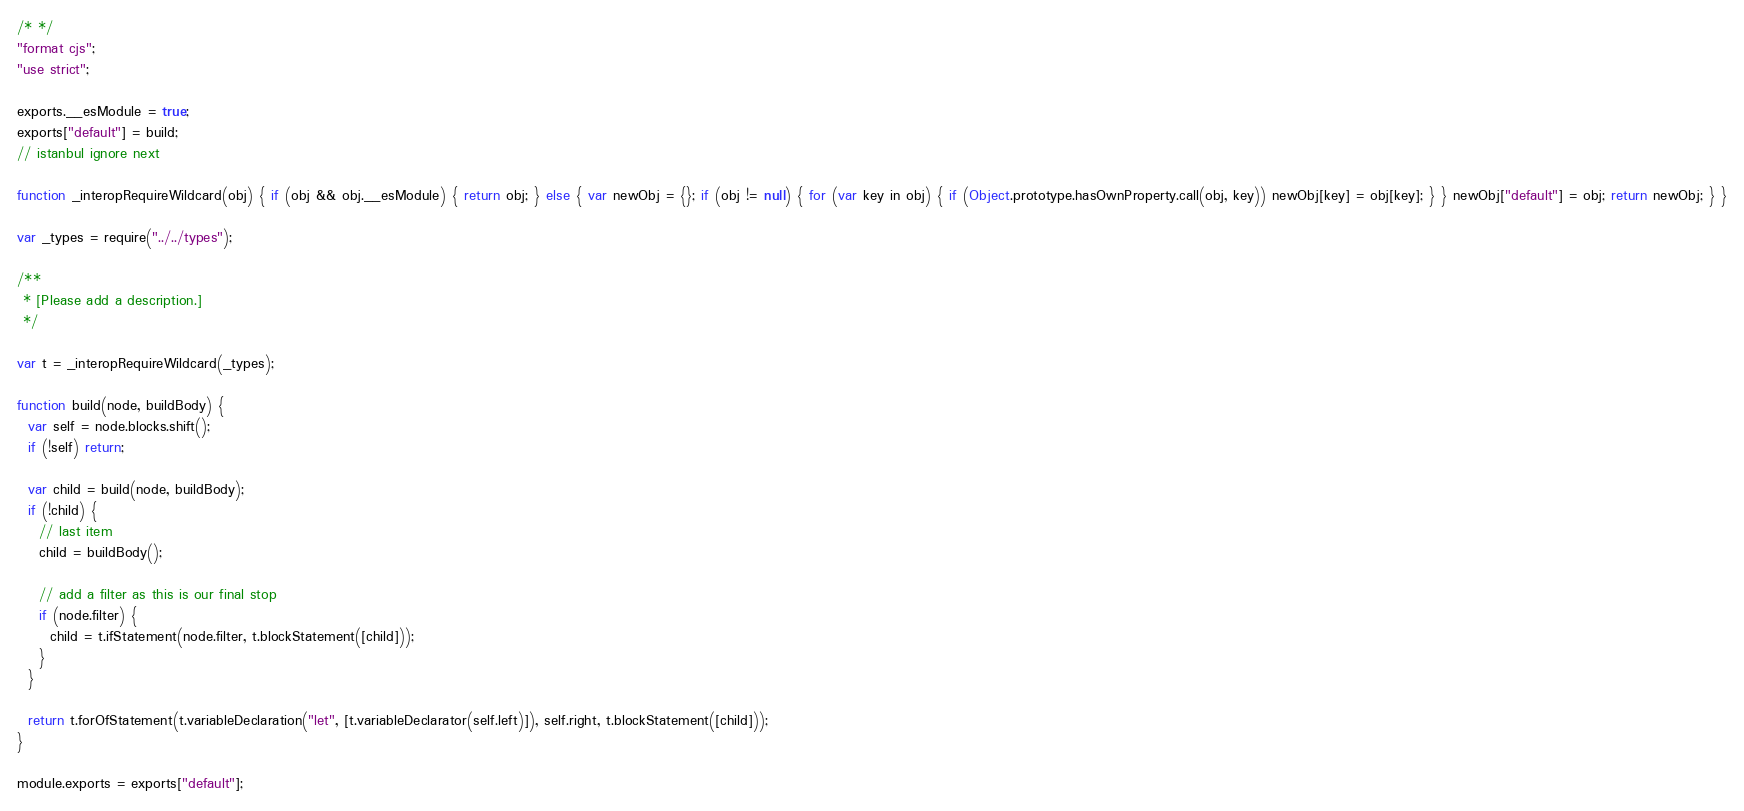<code> <loc_0><loc_0><loc_500><loc_500><_JavaScript_>/* */ 
"format cjs";
"use strict";

exports.__esModule = true;
exports["default"] = build;
// istanbul ignore next

function _interopRequireWildcard(obj) { if (obj && obj.__esModule) { return obj; } else { var newObj = {}; if (obj != null) { for (var key in obj) { if (Object.prototype.hasOwnProperty.call(obj, key)) newObj[key] = obj[key]; } } newObj["default"] = obj; return newObj; } }

var _types = require("../../types");

/**
 * [Please add a description.]
 */

var t = _interopRequireWildcard(_types);

function build(node, buildBody) {
  var self = node.blocks.shift();
  if (!self) return;

  var child = build(node, buildBody);
  if (!child) {
    // last item
    child = buildBody();

    // add a filter as this is our final stop
    if (node.filter) {
      child = t.ifStatement(node.filter, t.blockStatement([child]));
    }
  }

  return t.forOfStatement(t.variableDeclaration("let", [t.variableDeclarator(self.left)]), self.right, t.blockStatement([child]));
}

module.exports = exports["default"];</code> 